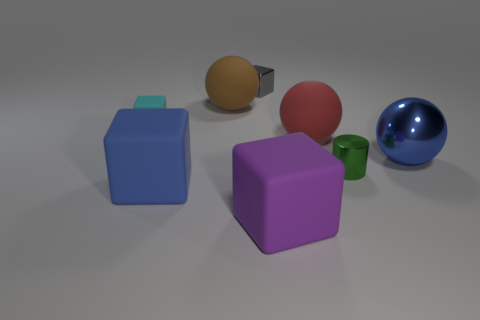Subtract all small gray blocks. How many blocks are left? 3 Subtract 1 balls. How many balls are left? 2 Subtract all purple cubes. How many cubes are left? 3 Add 1 tiny gray cubes. How many objects exist? 9 Subtract all spheres. How many objects are left? 5 Subtract all green spheres. Subtract all yellow blocks. How many spheres are left? 3 Add 1 small green cylinders. How many small green cylinders are left? 2 Add 1 big purple matte objects. How many big purple matte objects exist? 2 Subtract 0 brown cubes. How many objects are left? 8 Subtract all blue metal balls. Subtract all big brown spheres. How many objects are left? 6 